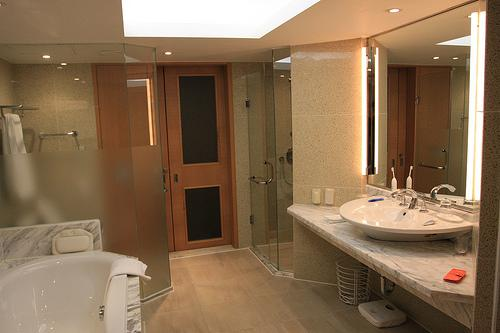Question: what room is this?
Choices:
A. Bedroom.
B. Bathroom.
C. Living Room.
D. Dining Room.
Answer with the letter. Answer: B Question: how many sinks are there?
Choices:
A. Two.
B. Three.
C. One.
D. Four.
Answer with the letter. Answer: C Question: who is in the tub?
Choices:
A. The baby.
B. The mother.
C. The dog.
D. No one.
Answer with the letter. Answer: D 